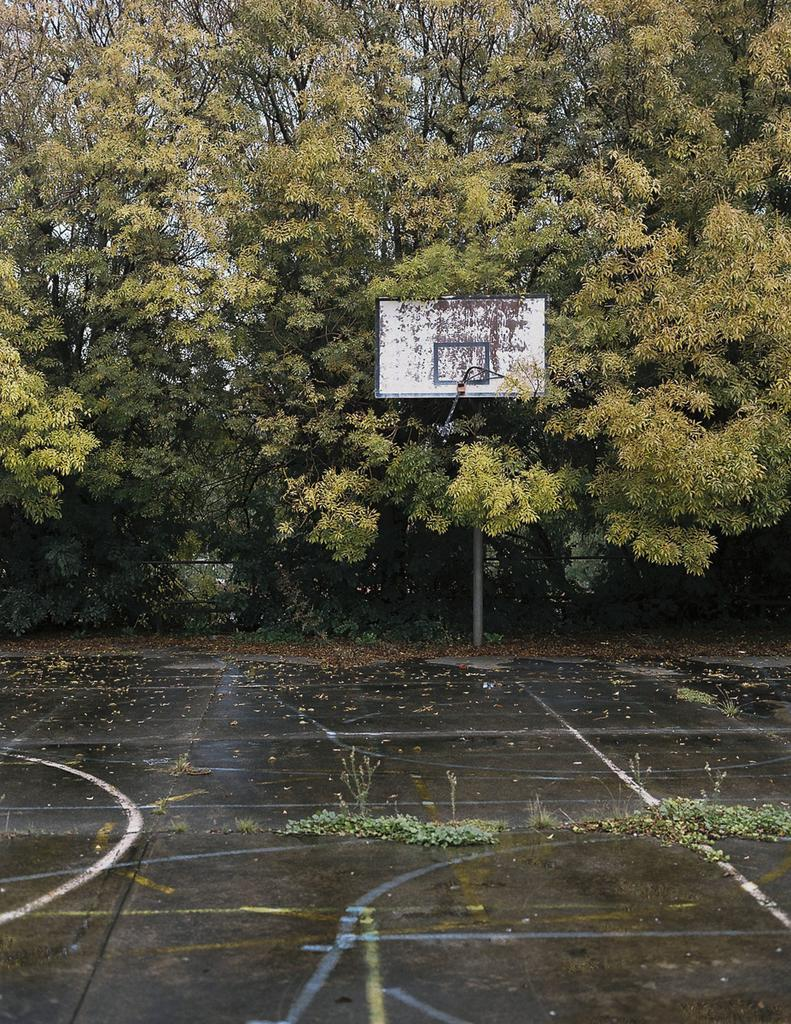What is the main structure visible in the image? There is a goal post in the image. What type of vegetation can be seen on the ground in the image? There are plants on the ground in the image. What can be seen in the background of the image? There is a group of trees in the image. What is visible above the ground in the image? The sky is visible in the image. How much money is being exchanged between the players in the image? There is no indication of money or players exchanging money in the image. 